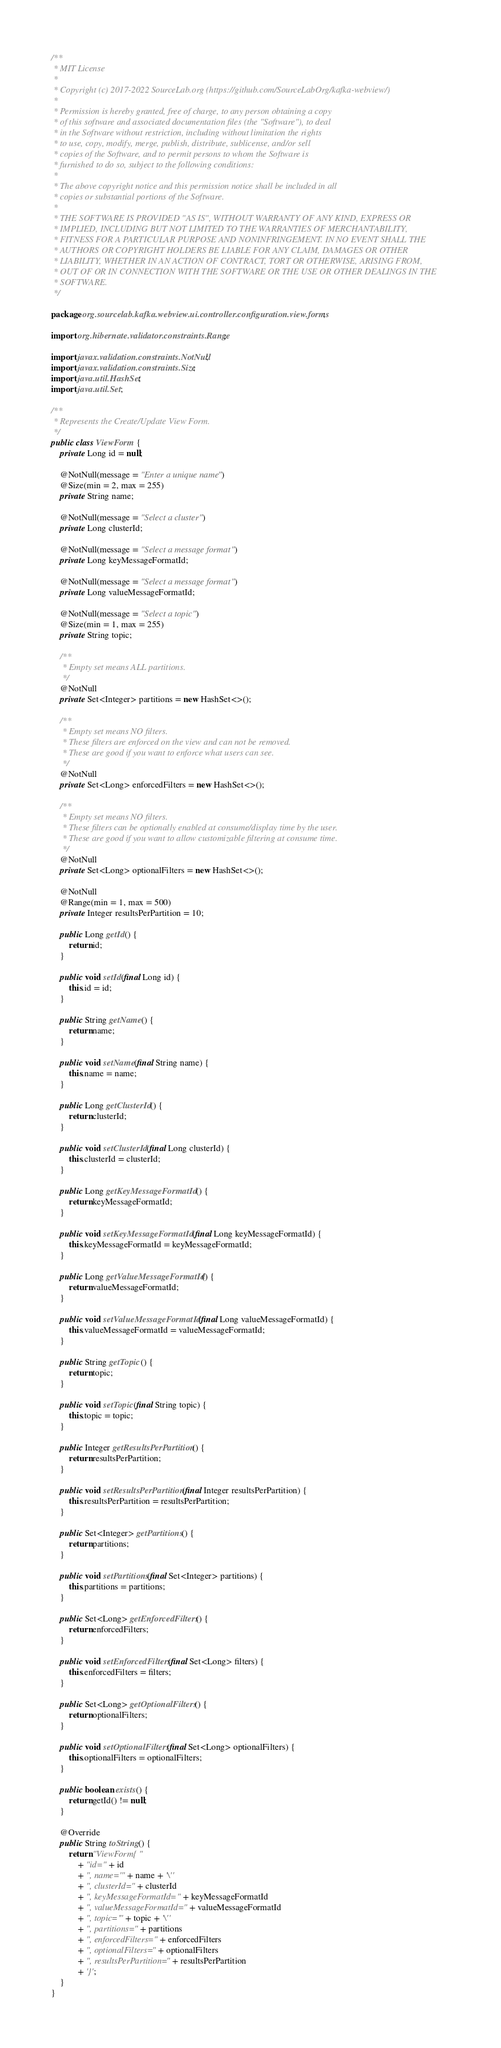<code> <loc_0><loc_0><loc_500><loc_500><_Java_>/**
 * MIT License
 *
 * Copyright (c) 2017-2022 SourceLab.org (https://github.com/SourceLabOrg/kafka-webview/)
 *
 * Permission is hereby granted, free of charge, to any person obtaining a copy
 * of this software and associated documentation files (the "Software"), to deal
 * in the Software without restriction, including without limitation the rights
 * to use, copy, modify, merge, publish, distribute, sublicense, and/or sell
 * copies of the Software, and to permit persons to whom the Software is
 * furnished to do so, subject to the following conditions:
 *
 * The above copyright notice and this permission notice shall be included in all
 * copies or substantial portions of the Software.
 *
 * THE SOFTWARE IS PROVIDED "AS IS", WITHOUT WARRANTY OF ANY KIND, EXPRESS OR
 * IMPLIED, INCLUDING BUT NOT LIMITED TO THE WARRANTIES OF MERCHANTABILITY,
 * FITNESS FOR A PARTICULAR PURPOSE AND NONINFRINGEMENT. IN NO EVENT SHALL THE
 * AUTHORS OR COPYRIGHT HOLDERS BE LIABLE FOR ANY CLAIM, DAMAGES OR OTHER
 * LIABILITY, WHETHER IN AN ACTION OF CONTRACT, TORT OR OTHERWISE, ARISING FROM,
 * OUT OF OR IN CONNECTION WITH THE SOFTWARE OR THE USE OR OTHER DEALINGS IN THE
 * SOFTWARE.
 */

package org.sourcelab.kafka.webview.ui.controller.configuration.view.forms;

import org.hibernate.validator.constraints.Range;

import javax.validation.constraints.NotNull;
import javax.validation.constraints.Size;
import java.util.HashSet;
import java.util.Set;

/**
 * Represents the Create/Update View Form.
 */
public class ViewForm {
    private Long id = null;

    @NotNull(message = "Enter a unique name")
    @Size(min = 2, max = 255)
    private String name;

    @NotNull(message = "Select a cluster")
    private Long clusterId;

    @NotNull(message = "Select a message format")
    private Long keyMessageFormatId;

    @NotNull(message = "Select a message format")
    private Long valueMessageFormatId;

    @NotNull(message = "Select a topic")
    @Size(min = 1, max = 255)
    private String topic;

    /**
     * Empty set means ALL partitions.
     */
    @NotNull
    private Set<Integer> partitions = new HashSet<>();

    /**
     * Empty set means NO filters.
     * These filters are enforced on the view and can not be removed.
     * These are good if you want to enforce what users can see.
     */
    @NotNull
    private Set<Long> enforcedFilters = new HashSet<>();

    /**
     * Empty set means NO filters.
     * These filters can be optionally enabled at consume/display time by the user.
     * These are good if you want to allow customizable filtering at consume time.
     */
    @NotNull
    private Set<Long> optionalFilters = new HashSet<>();

    @NotNull
    @Range(min = 1, max = 500)
    private Integer resultsPerPartition = 10;

    public Long getId() {
        return id;
    }

    public void setId(final Long id) {
        this.id = id;
    }

    public String getName() {
        return name;
    }

    public void setName(final String name) {
        this.name = name;
    }

    public Long getClusterId() {
        return clusterId;
    }

    public void setClusterId(final Long clusterId) {
        this.clusterId = clusterId;
    }

    public Long getKeyMessageFormatId() {
        return keyMessageFormatId;
    }

    public void setKeyMessageFormatId(final Long keyMessageFormatId) {
        this.keyMessageFormatId = keyMessageFormatId;
    }

    public Long getValueMessageFormatId() {
        return valueMessageFormatId;
    }

    public void setValueMessageFormatId(final Long valueMessageFormatId) {
        this.valueMessageFormatId = valueMessageFormatId;
    }

    public String getTopic() {
        return topic;
    }

    public void setTopic(final String topic) {
        this.topic = topic;
    }

    public Integer getResultsPerPartition() {
        return resultsPerPartition;
    }

    public void setResultsPerPartition(final Integer resultsPerPartition) {
        this.resultsPerPartition = resultsPerPartition;
    }

    public Set<Integer> getPartitions() {
        return partitions;
    }

    public void setPartitions(final Set<Integer> partitions) {
        this.partitions = partitions;
    }

    public Set<Long> getEnforcedFilters() {
        return enforcedFilters;
    }

    public void setEnforcedFilters(final Set<Long> filters) {
        this.enforcedFilters = filters;
    }

    public Set<Long> getOptionalFilters() {
        return optionalFilters;
    }

    public void setOptionalFilters(final Set<Long> optionalFilters) {
        this.optionalFilters = optionalFilters;
    }

    public boolean exists() {
        return getId() != null;
    }

    @Override
    public String toString() {
        return "ViewForm{"
            + "id=" + id
            + ", name='" + name + '\''
            + ", clusterId=" + clusterId
            + ", keyMessageFormatId=" + keyMessageFormatId
            + ", valueMessageFormatId=" + valueMessageFormatId
            + ", topic='" + topic + '\''
            + ", partitions=" + partitions
            + ", enforcedFilters=" + enforcedFilters
            + ", optionalFilters=" + optionalFilters
            + ", resultsPerPartition=" + resultsPerPartition
            + '}';
    }
}
</code> 